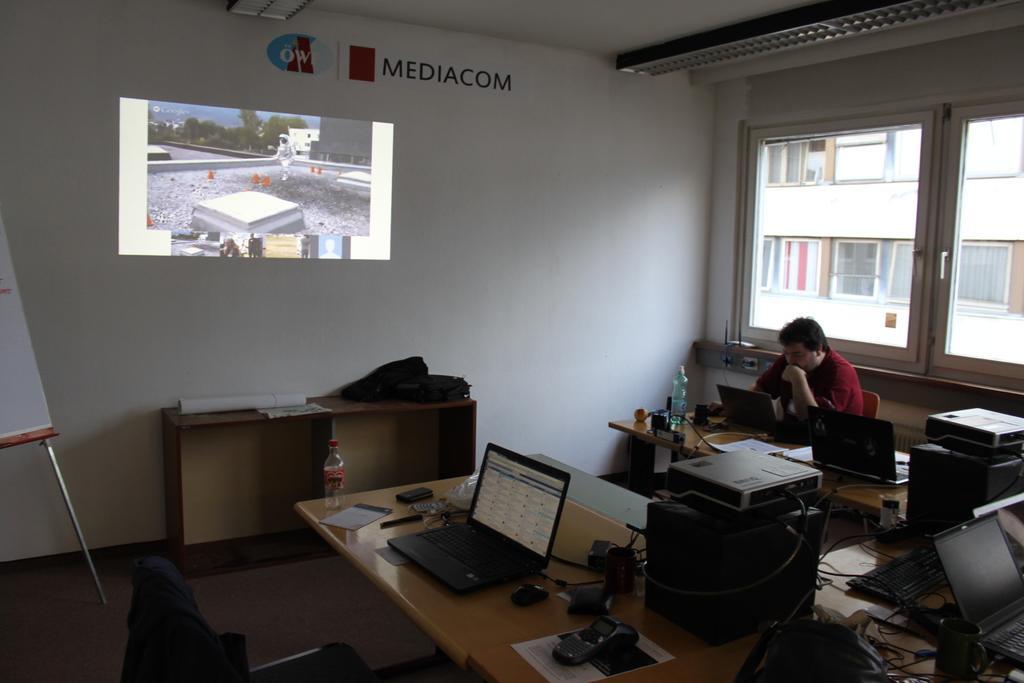Describe this image in one or two sentences. It is inside an office there are some computers, laptops and keyboards on the table ,a man is sitting on the chair to the right side he is wearing red color shirt ,on the wall there is a projector and also the company name, the wall is of white color ,in the background there is a window and outside the window there is building. 